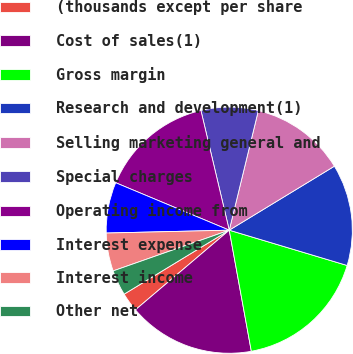Convert chart to OTSL. <chart><loc_0><loc_0><loc_500><loc_500><pie_chart><fcel>(thousands except per share<fcel>Cost of sales(1)<fcel>Gross margin<fcel>Research and development(1)<fcel>Selling marketing general and<fcel>Special charges<fcel>Operating income from<fcel>Interest expense<fcel>Interest income<fcel>Other net<nl><fcel>2.5%<fcel>16.67%<fcel>17.5%<fcel>13.33%<fcel>12.5%<fcel>7.5%<fcel>15.0%<fcel>6.67%<fcel>5.0%<fcel>3.33%<nl></chart> 